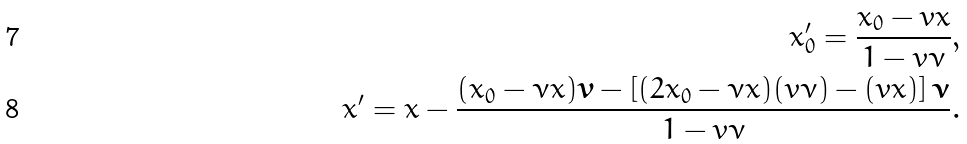Convert formula to latex. <formula><loc_0><loc_0><loc_500><loc_500>x ^ { \prime } _ { 0 } = \frac { x _ { 0 } - v x } { 1 - v \nu } , \\ x ^ { \prime } = x - \frac { ( x _ { 0 } - \nu x ) \boldsymbol v - \left [ ( 2 x _ { 0 } - \nu x ) ( v \nu ) - ( v x ) \right ] \boldsymbol \nu } { 1 - v \nu } .</formula> 